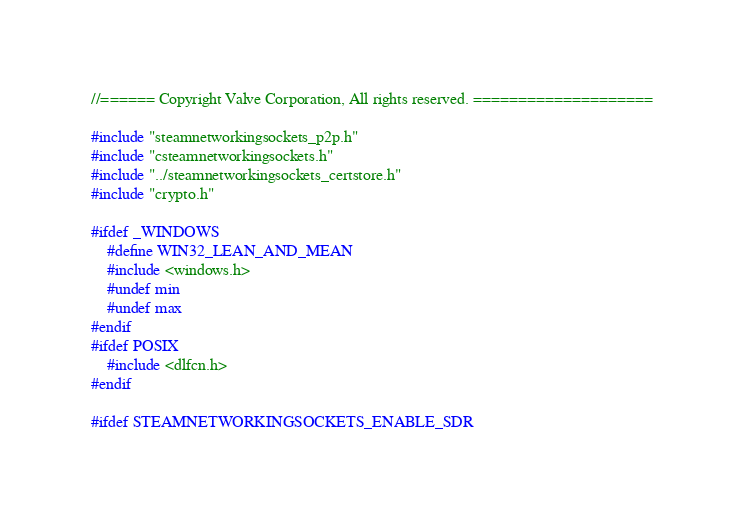Convert code to text. <code><loc_0><loc_0><loc_500><loc_500><_C++_>//====== Copyright Valve Corporation, All rights reserved. ====================

#include "steamnetworkingsockets_p2p.h"
#include "csteamnetworkingsockets.h"
#include "../steamnetworkingsockets_certstore.h"
#include "crypto.h"

#ifdef _WINDOWS
	#define WIN32_LEAN_AND_MEAN
	#include <windows.h>
	#undef min
	#undef max
#endif
#ifdef POSIX
	#include <dlfcn.h>
#endif

#ifdef STEAMNETWORKINGSOCKETS_ENABLE_SDR</code> 